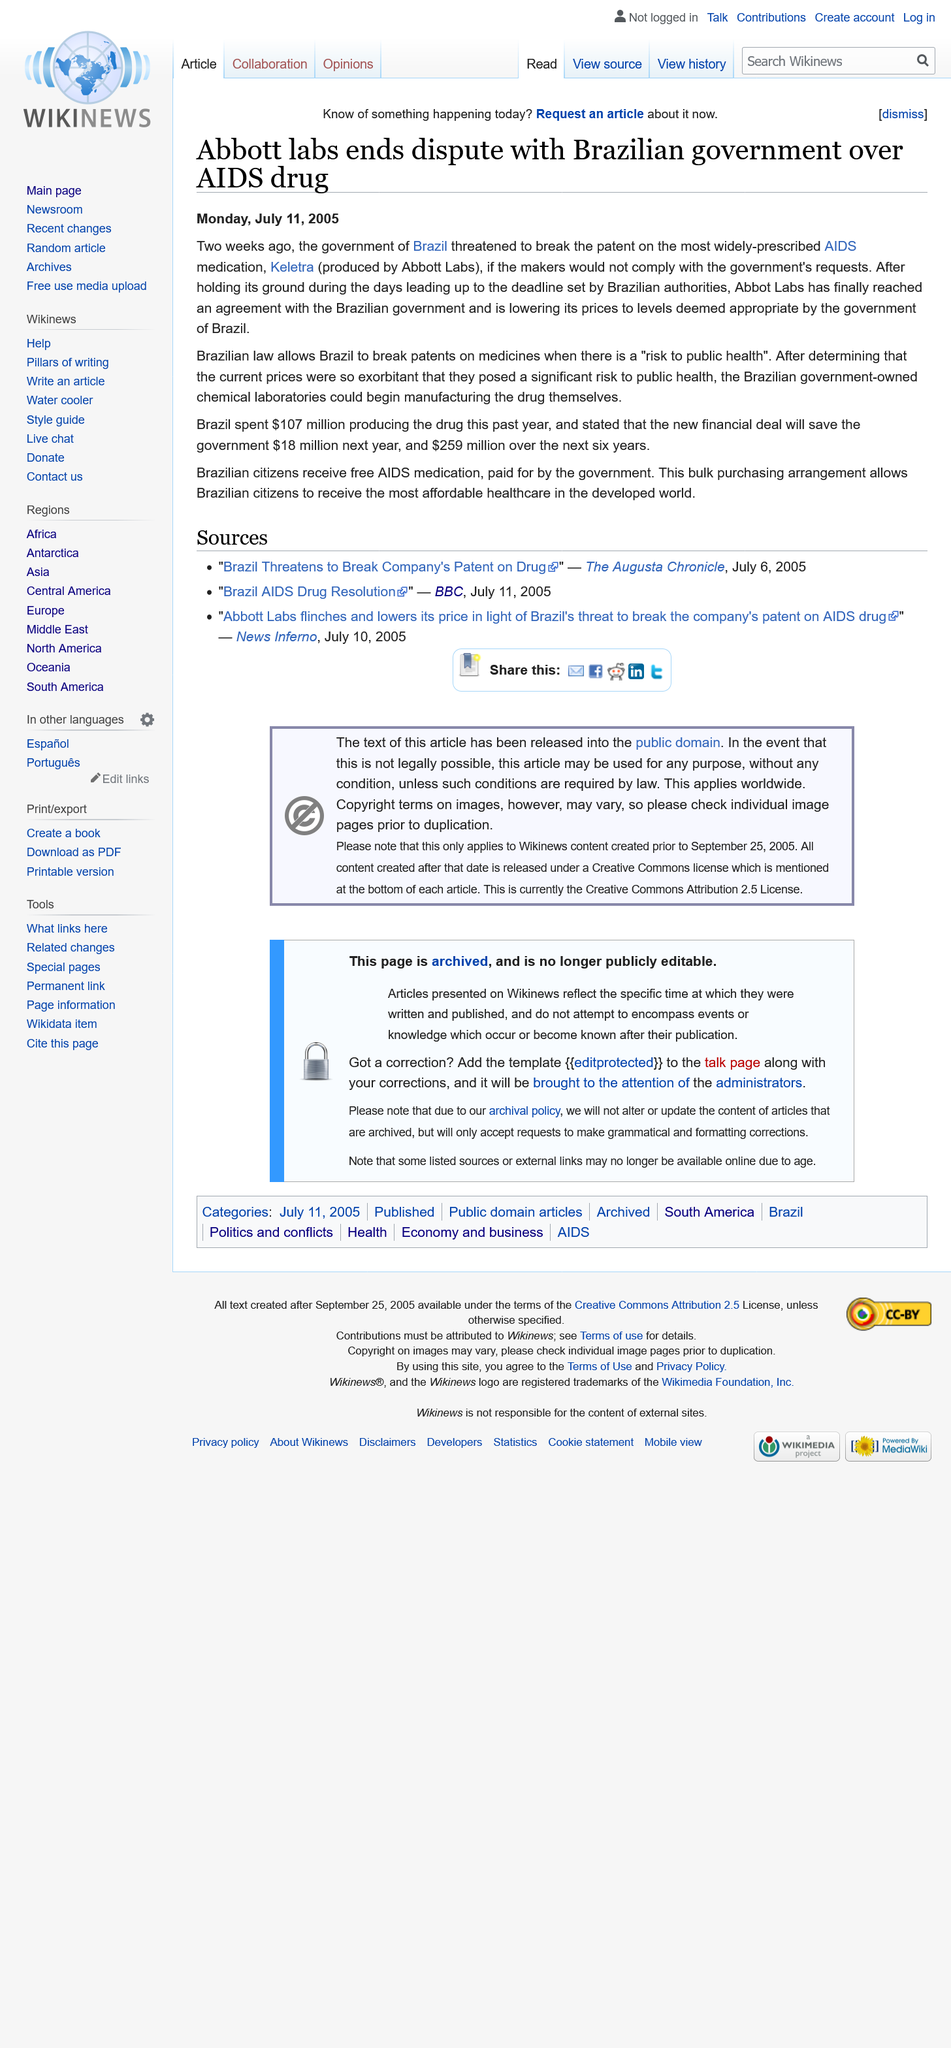Give some essential details in this illustration. In June 2005, the Brazilian government threatened to break the patent for Keletra. Keletra, a medication produced by Abbott Labs, is named after the company that produces it. Brazil spent $107 million in the past year on producing Keletra. 